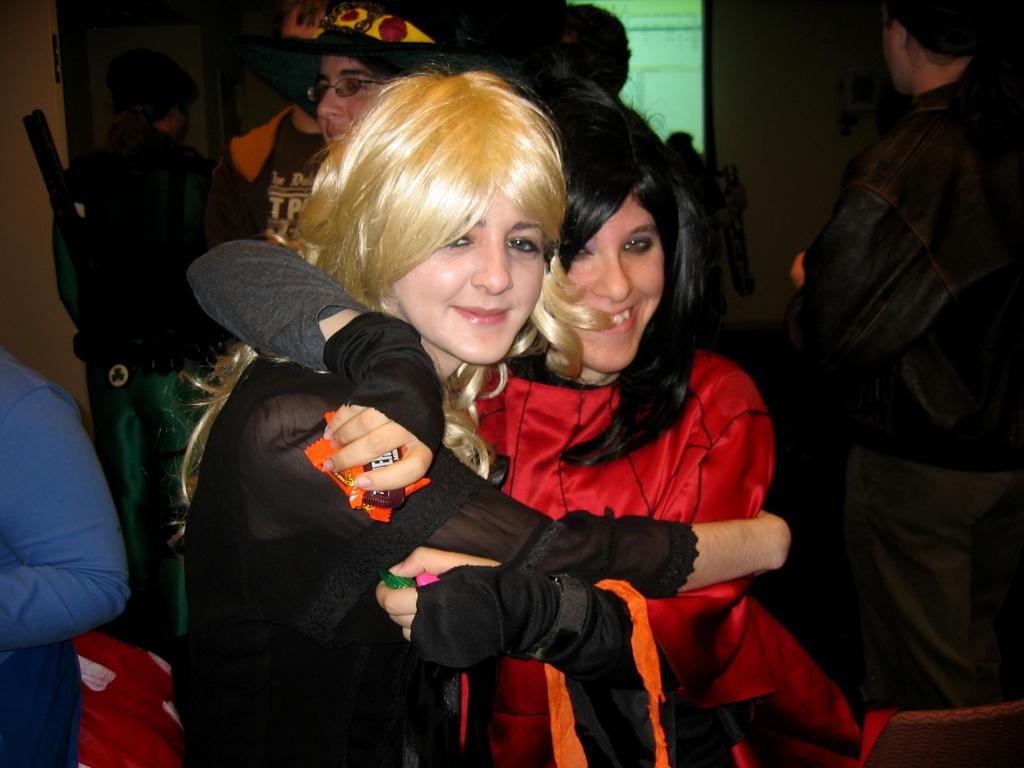How many women are in the image? There are two women in the image. What expressions do the women have? The women are smiling. What colors are the dresses worn by the women? One woman is wearing a black dress, and the other woman is wearing a red dress. What can be seen in the background of the image? There are people standing in the background of the image, and there is a wall visible as well. Who is the creator of the light bulb in the image? There is no light bulb present in the image, so it is not possible to determine who created it. 